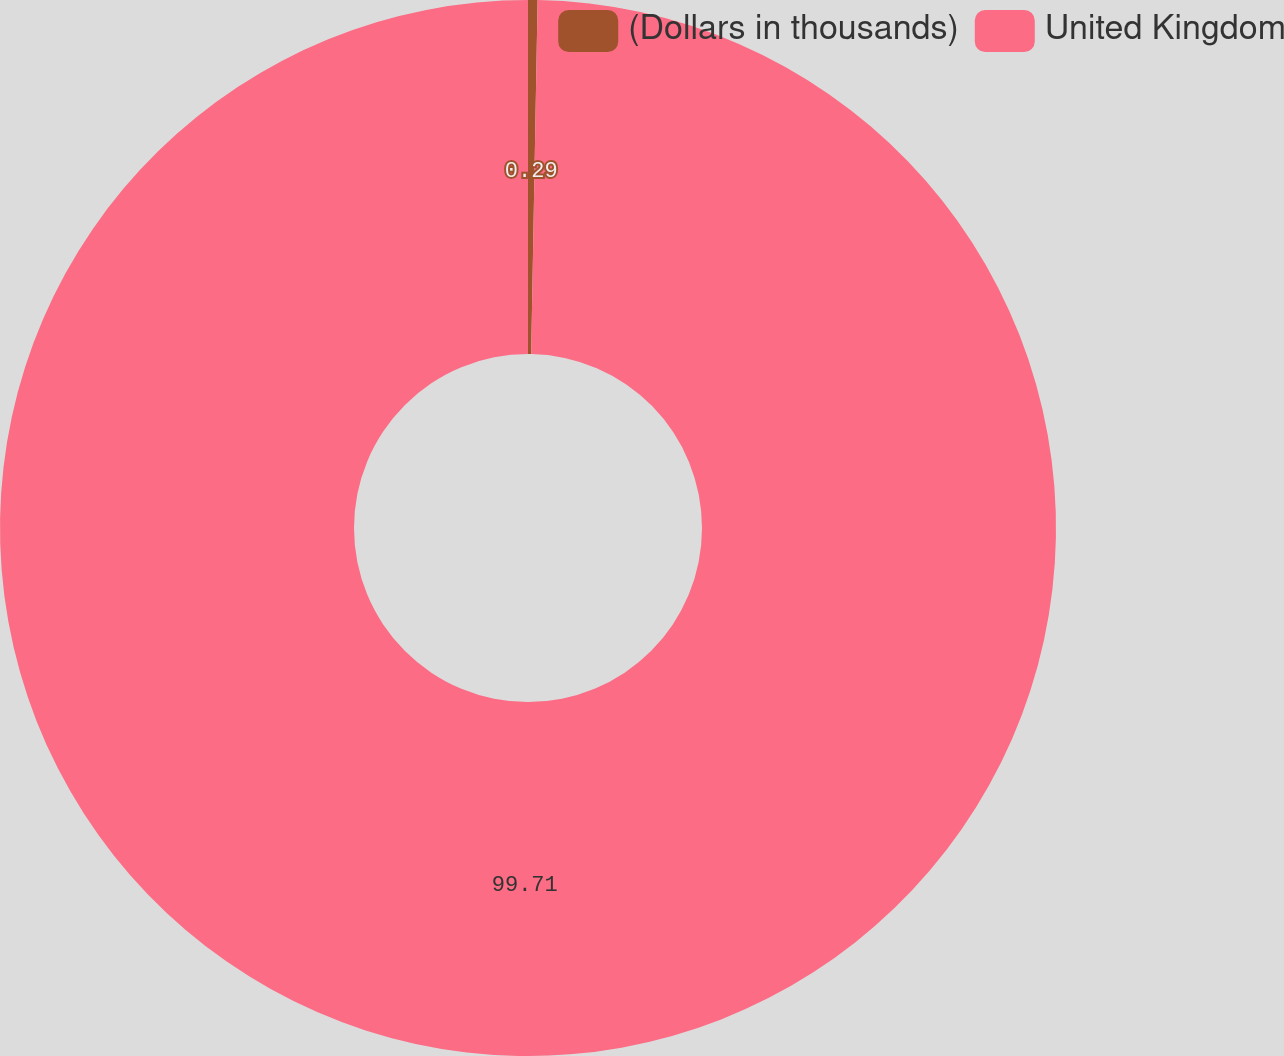Convert chart. <chart><loc_0><loc_0><loc_500><loc_500><pie_chart><fcel>(Dollars in thousands)<fcel>United Kingdom<nl><fcel>0.29%<fcel>99.71%<nl></chart> 